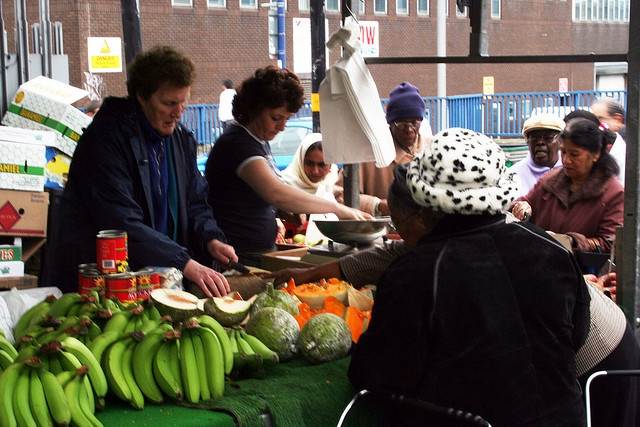Describe the objects in this image and their specific colors. I can see people in gray, black, white, and darkgray tones, people in gray, black, maroon, navy, and brown tones, people in gray, black, maroon, brown, and lightgray tones, people in gray, black, maroon, and brown tones, and people in gray, black, brown, and maroon tones in this image. 